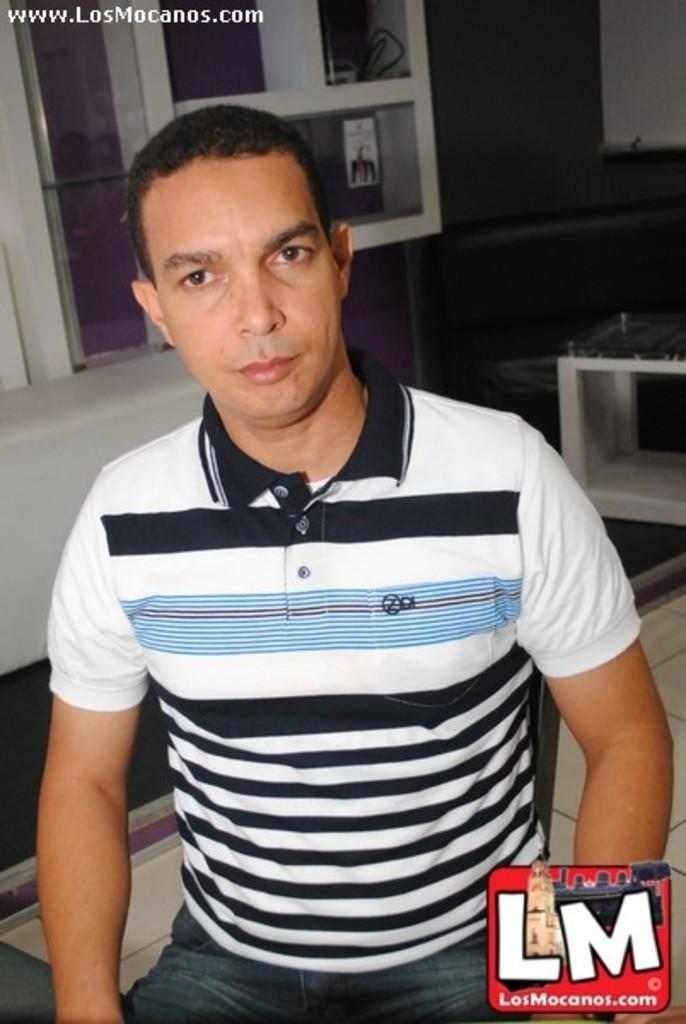<image>
Describe the image concisely. A man uploaded a photograph of himself to LosMonacos.com. 